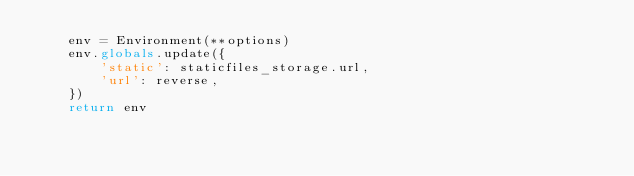Convert code to text. <code><loc_0><loc_0><loc_500><loc_500><_Python_>    env = Environment(**options)
    env.globals.update({
        'static': staticfiles_storage.url,
        'url': reverse,
    })
    return env</code> 